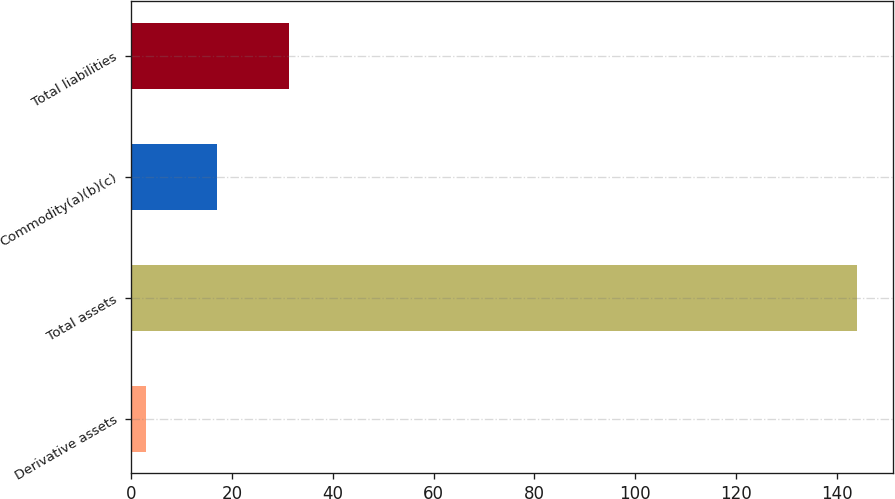Convert chart. <chart><loc_0><loc_0><loc_500><loc_500><bar_chart><fcel>Derivative assets<fcel>Total assets<fcel>Commodity(a)(b)(c)<fcel>Total liabilities<nl><fcel>3<fcel>144<fcel>17.1<fcel>31.2<nl></chart> 